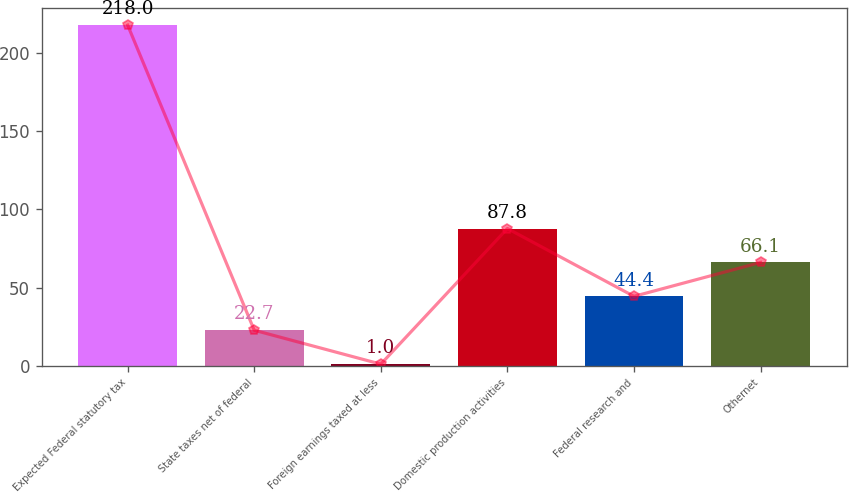Convert chart to OTSL. <chart><loc_0><loc_0><loc_500><loc_500><bar_chart><fcel>Expected Federal statutory tax<fcel>State taxes net of federal<fcel>Foreign earnings taxed at less<fcel>Domestic production activities<fcel>Federal research and<fcel>Othernet<nl><fcel>218<fcel>22.7<fcel>1<fcel>87.8<fcel>44.4<fcel>66.1<nl></chart> 